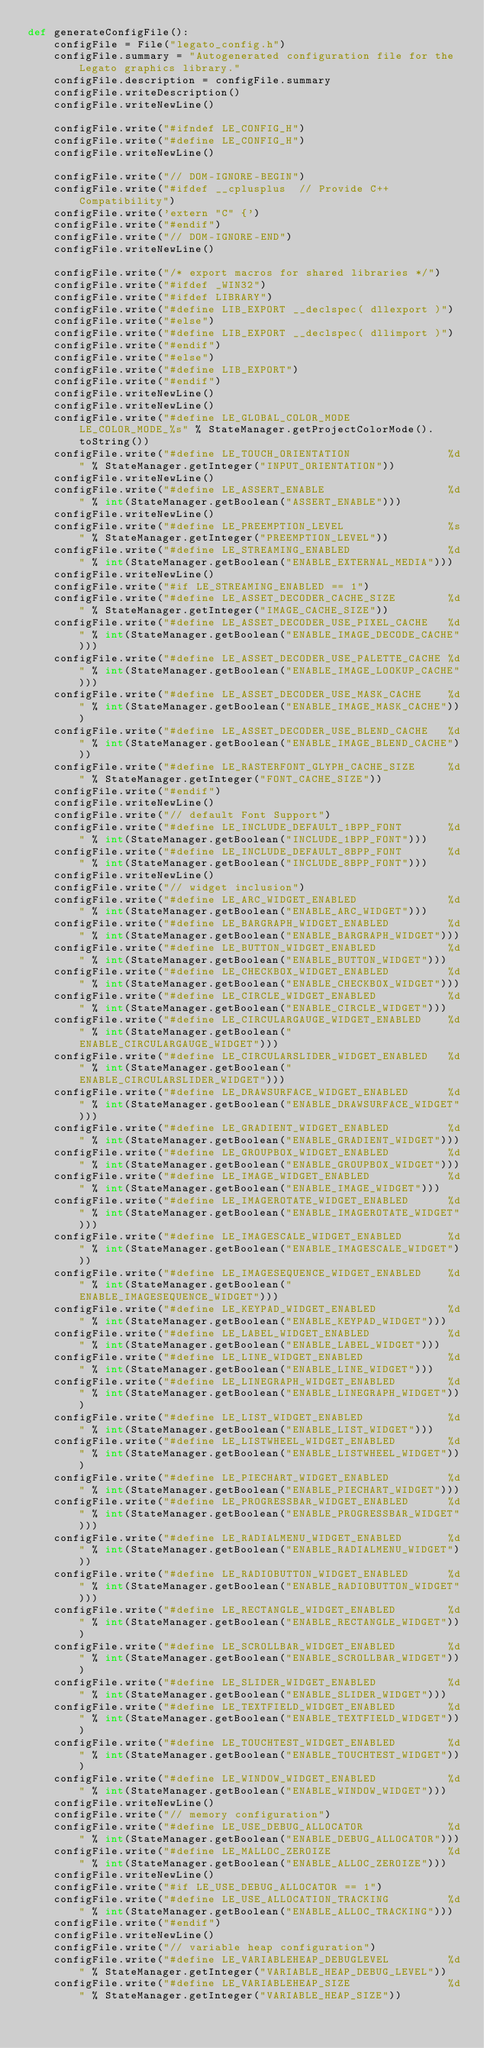<code> <loc_0><loc_0><loc_500><loc_500><_Python_>def generateConfigFile():
	configFile = File("legato_config.h")
	configFile.summary = "Autogenerated configuration file for the Legato graphics library."
	configFile.description = configFile.summary
	configFile.writeDescription()
	configFile.writeNewLine()
	
	configFile.write("#ifndef LE_CONFIG_H")
	configFile.write("#define LE_CONFIG_H")
	configFile.writeNewLine()
	
	configFile.write("// DOM-IGNORE-BEGIN")
	configFile.write("#ifdef __cplusplus  // Provide C++ Compatibility")
	configFile.write('extern "C" {')
	configFile.write("#endif")
	configFile.write("// DOM-IGNORE-END")
	configFile.writeNewLine()
	
	configFile.write("/* export macros for shared libraries */")
	configFile.write("#ifdef _WIN32")
	configFile.write("#ifdef LIBRARY")
	configFile.write("#define LIB_EXPORT __declspec( dllexport )")
	configFile.write("#else")
	configFile.write("#define LIB_EXPORT __declspec( dllimport )")
	configFile.write("#endif")
	configFile.write("#else")
	configFile.write("#define LIB_EXPORT")
	configFile.write("#endif")
	configFile.writeNewLine()
	configFile.writeNewLine()
	configFile.write("#define LE_GLOBAL_COLOR_MODE               LE_COLOR_MODE_%s" % StateManager.getProjectColorMode().toString())
	configFile.write("#define LE_TOUCH_ORIENTATION               %d" % StateManager.getInteger("INPUT_ORIENTATION"))
	configFile.writeNewLine()
	configFile.write("#define LE_ASSERT_ENABLE                   %d" % int(StateManager.getBoolean("ASSERT_ENABLE")))
	configFile.writeNewLine()
	configFile.write("#define LE_PREEMPTION_LEVEL                %s" % StateManager.getInteger("PREEMPTION_LEVEL"))
	configFile.write("#define LE_STREAMING_ENABLED               %d" % int(StateManager.getBoolean("ENABLE_EXTERNAL_MEDIA")))
	configFile.writeNewLine()
	configFile.write("#if LE_STREAMING_ENABLED == 1")
	configFile.write("#define LE_ASSET_DECODER_CACHE_SIZE        %d" % StateManager.getInteger("IMAGE_CACHE_SIZE"))
	configFile.write("#define LE_ASSET_DECODER_USE_PIXEL_CACHE   %d" % int(StateManager.getBoolean("ENABLE_IMAGE_DECODE_CACHE")))
	configFile.write("#define LE_ASSET_DECODER_USE_PALETTE_CACHE %d" % int(StateManager.getBoolean("ENABLE_IMAGE_LOOKUP_CACHE")))
	configFile.write("#define LE_ASSET_DECODER_USE_MASK_CACHE    %d" % int(StateManager.getBoolean("ENABLE_IMAGE_MASK_CACHE")))
	configFile.write("#define LE_ASSET_DECODER_USE_BLEND_CACHE   %d" % int(StateManager.getBoolean("ENABLE_IMAGE_BLEND_CACHE")))
	configFile.write("#define LE_RASTERFONT_GLYPH_CACHE_SIZE     %d" % StateManager.getInteger("FONT_CACHE_SIZE"))
	configFile.write("#endif")
	configFile.writeNewLine()
	configFile.write("// default Font Support")
	configFile.write("#define LE_INCLUDE_DEFAULT_1BPP_FONT       %d" % int(StateManager.getBoolean("INCLUDE_1BPP_FONT")))
	configFile.write("#define LE_INCLUDE_DEFAULT_8BPP_FONT       %d" % int(StateManager.getBoolean("INCLUDE_8BPP_FONT")))
	configFile.writeNewLine()
	configFile.write("// widget inclusion")
	configFile.write("#define LE_ARC_WIDGET_ENABLED              %d" % int(StateManager.getBoolean("ENABLE_ARC_WIDGET")))
	configFile.write("#define LE_BARGRAPH_WIDGET_ENABLED         %d" % int(StateManager.getBoolean("ENABLE_BARGRAPH_WIDGET")))
	configFile.write("#define LE_BUTTON_WIDGET_ENABLED           %d" % int(StateManager.getBoolean("ENABLE_BUTTON_WIDGET")))
	configFile.write("#define LE_CHECKBOX_WIDGET_ENABLED         %d" % int(StateManager.getBoolean("ENABLE_CHECKBOX_WIDGET")))
	configFile.write("#define LE_CIRCLE_WIDGET_ENABLED           %d" % int(StateManager.getBoolean("ENABLE_CIRCLE_WIDGET")))
	configFile.write("#define LE_CIRCULARGAUGE_WIDGET_ENABLED    %d" % int(StateManager.getBoolean("ENABLE_CIRCULARGAUGE_WIDGET")))
	configFile.write("#define LE_CIRCULARSLIDER_WIDGET_ENABLED   %d" % int(StateManager.getBoolean("ENABLE_CIRCULARSLIDER_WIDGET")))
	configFile.write("#define LE_DRAWSURFACE_WIDGET_ENABLED      %d" % int(StateManager.getBoolean("ENABLE_DRAWSURFACE_WIDGET")))
	configFile.write("#define LE_GRADIENT_WIDGET_ENABLED         %d" % int(StateManager.getBoolean("ENABLE_GRADIENT_WIDGET")))
	configFile.write("#define LE_GROUPBOX_WIDGET_ENABLED         %d" % int(StateManager.getBoolean("ENABLE_GROUPBOX_WIDGET")))
	configFile.write("#define LE_IMAGE_WIDGET_ENABLED            %d" % int(StateManager.getBoolean("ENABLE_IMAGE_WIDGET")))
	configFile.write("#define LE_IMAGEROTATE_WIDGET_ENABLED      %d" % int(StateManager.getBoolean("ENABLE_IMAGEROTATE_WIDGET")))
	configFile.write("#define LE_IMAGESCALE_WIDGET_ENABLED       %d" % int(StateManager.getBoolean("ENABLE_IMAGESCALE_WIDGET")))
	configFile.write("#define LE_IMAGESEQUENCE_WIDGET_ENABLED    %d" % int(StateManager.getBoolean("ENABLE_IMAGESEQUENCE_WIDGET")))
	configFile.write("#define LE_KEYPAD_WIDGET_ENABLED           %d" % int(StateManager.getBoolean("ENABLE_KEYPAD_WIDGET")))
	configFile.write("#define LE_LABEL_WIDGET_ENABLED            %d" % int(StateManager.getBoolean("ENABLE_LABEL_WIDGET")))
	configFile.write("#define LE_LINE_WIDGET_ENABLED             %d" % int(StateManager.getBoolean("ENABLE_LINE_WIDGET")))
	configFile.write("#define LE_LINEGRAPH_WIDGET_ENABLED        %d" % int(StateManager.getBoolean("ENABLE_LINEGRAPH_WIDGET")))
	configFile.write("#define LE_LIST_WIDGET_ENABLED             %d" % int(StateManager.getBoolean("ENABLE_LIST_WIDGET")))
	configFile.write("#define LE_LISTWHEEL_WIDGET_ENABLED        %d" % int(StateManager.getBoolean("ENABLE_LISTWHEEL_WIDGET")))
	configFile.write("#define LE_PIECHART_WIDGET_ENABLED         %d" % int(StateManager.getBoolean("ENABLE_PIECHART_WIDGET")))
	configFile.write("#define LE_PROGRESSBAR_WIDGET_ENABLED      %d" % int(StateManager.getBoolean("ENABLE_PROGRESSBAR_WIDGET")))
	configFile.write("#define LE_RADIALMENU_WIDGET_ENABLED       %d" % int(StateManager.getBoolean("ENABLE_RADIALMENU_WIDGET")))
	configFile.write("#define LE_RADIOBUTTON_WIDGET_ENABLED      %d" % int(StateManager.getBoolean("ENABLE_RADIOBUTTON_WIDGET")))
	configFile.write("#define LE_RECTANGLE_WIDGET_ENABLED        %d" % int(StateManager.getBoolean("ENABLE_RECTANGLE_WIDGET")))
	configFile.write("#define LE_SCROLLBAR_WIDGET_ENABLED        %d" % int(StateManager.getBoolean("ENABLE_SCROLLBAR_WIDGET")))
	configFile.write("#define LE_SLIDER_WIDGET_ENABLED           %d" % int(StateManager.getBoolean("ENABLE_SLIDER_WIDGET")))
	configFile.write("#define LE_TEXTFIELD_WIDGET_ENABLED        %d" % int(StateManager.getBoolean("ENABLE_TEXTFIELD_WIDGET")))
	configFile.write("#define LE_TOUCHTEST_WIDGET_ENABLED        %d" % int(StateManager.getBoolean("ENABLE_TOUCHTEST_WIDGET")))
	configFile.write("#define LE_WINDOW_WIDGET_ENABLED           %d" % int(StateManager.getBoolean("ENABLE_WINDOW_WIDGET")))
	configFile.writeNewLine()
	configFile.write("// memory configuration")
	configFile.write("#define LE_USE_DEBUG_ALLOCATOR             %d" % int(StateManager.getBoolean("ENABLE_DEBUG_ALLOCATOR")))
	configFile.write("#define LE_MALLOC_ZEROIZE                  %d" % int(StateManager.getBoolean("ENABLE_ALLOC_ZEROIZE")))
	configFile.writeNewLine()
	configFile.write("#if LE_USE_DEBUG_ALLOCATOR == 1")
	configFile.write("#define LE_USE_ALLOCATION_TRACKING         %d" % int(StateManager.getBoolean("ENABLE_ALLOC_TRACKING")))
	configFile.write("#endif")
	configFile.writeNewLine()
	configFile.write("// variable heap configuration")
	configFile.write("#define LE_VARIABLEHEAP_DEBUGLEVEL         %d" % StateManager.getInteger("VARIABLE_HEAP_DEBUG_LEVEL"))
	configFile.write("#define LE_VARIABLEHEAP_SIZE               %d" % StateManager.getInteger("VARIABLE_HEAP_SIZE"))</code> 